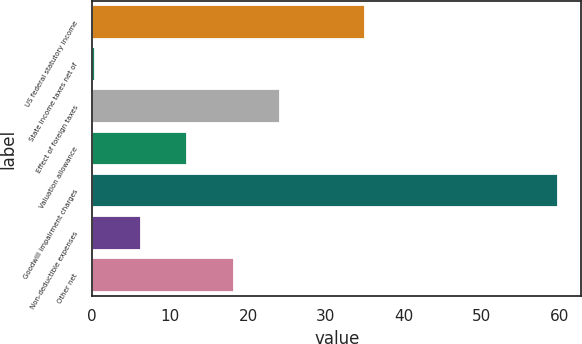Convert chart to OTSL. <chart><loc_0><loc_0><loc_500><loc_500><bar_chart><fcel>US federal statutory income<fcel>State income taxes net of<fcel>Effect of foreign taxes<fcel>Valuation allowance<fcel>Goodwill impairment charges<fcel>Non-deductible expenses<fcel>Other net<nl><fcel>35<fcel>0.3<fcel>24.1<fcel>12.2<fcel>59.8<fcel>6.25<fcel>18.15<nl></chart> 